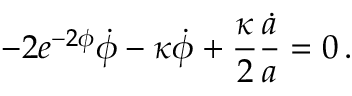<formula> <loc_0><loc_0><loc_500><loc_500>- 2 e ^ { - 2 \phi } \dot { \phi } - \kappa \dot { \phi } + \frac { \kappa } { 2 } \frac { \dot { a } } { a } = 0 \, .</formula> 